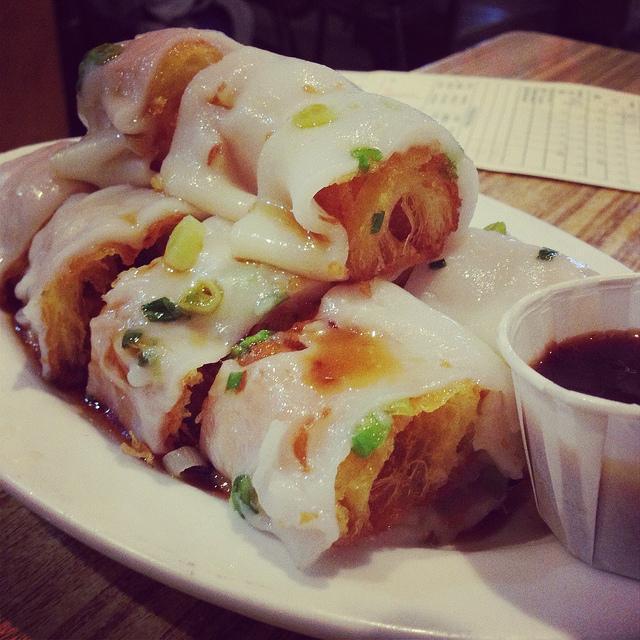How many shirts is this person wearing?
Give a very brief answer. 0. 